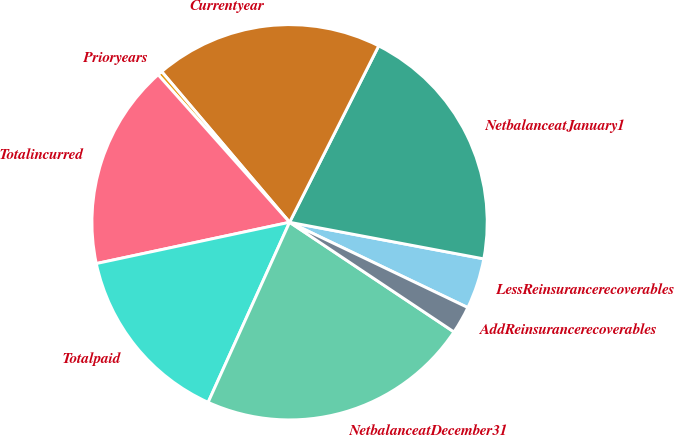<chart> <loc_0><loc_0><loc_500><loc_500><pie_chart><fcel>LessReinsurancerecoverables<fcel>NetbalanceatJanuary1<fcel>Currentyear<fcel>Prioryears<fcel>Totalincurred<fcel>Totalpaid<fcel>NetbalanceatDecember31<fcel>AddReinsurancerecoverables<nl><fcel>4.14%<fcel>20.52%<fcel>18.65%<fcel>0.38%<fcel>16.77%<fcel>14.89%<fcel>22.4%<fcel>2.26%<nl></chart> 